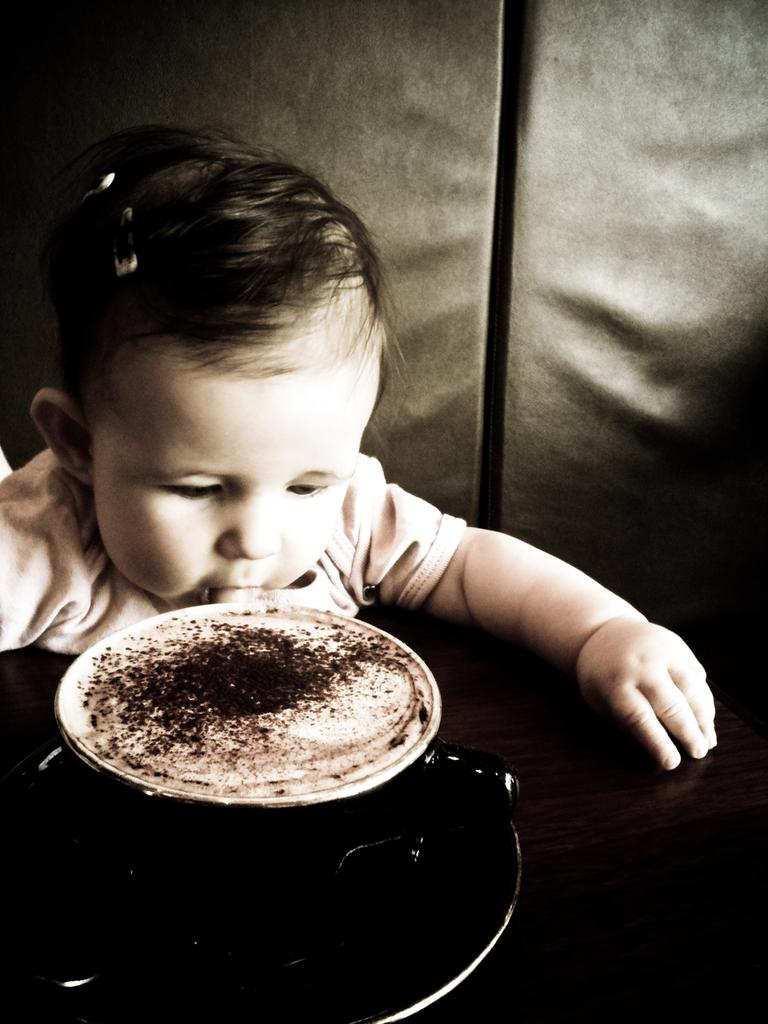What is the main subject of the image? The main subject of the image is a kid. What is in front of the kid? There is a cup with a drink in it in front of the kid. What type of mitten is the kid wearing in the image? There is no mitten visible in the image. What is the texture of the cup in the image? The texture of the cup cannot be determined from the image alone. 